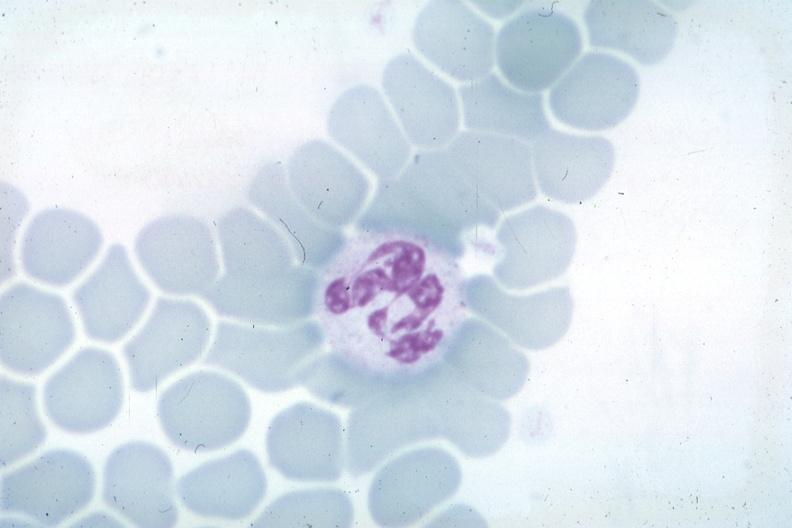does this image show wrights not the best photograph for color?
Answer the question using a single word or phrase. Yes 